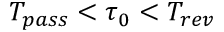Convert formula to latex. <formula><loc_0><loc_0><loc_500><loc_500>T _ { p a s s } < \tau _ { 0 } < T _ { r e v }</formula> 